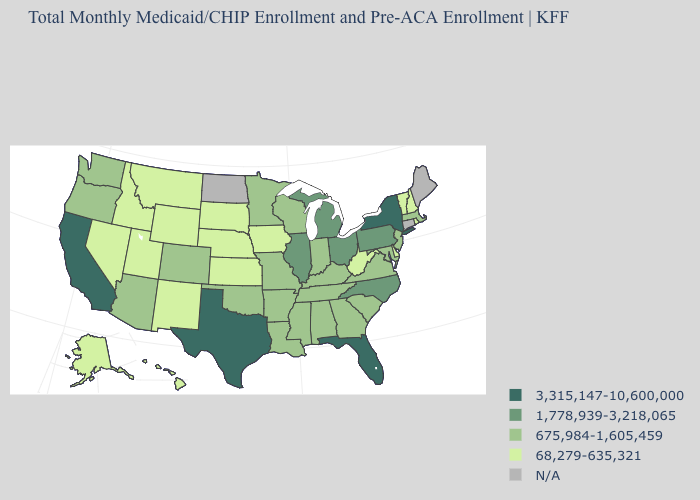What is the highest value in states that border New Jersey?
Give a very brief answer. 3,315,147-10,600,000. Does Idaho have the lowest value in the West?
Short answer required. Yes. What is the lowest value in the Northeast?
Give a very brief answer. 68,279-635,321. Name the states that have a value in the range 68,279-635,321?
Short answer required. Alaska, Delaware, Hawaii, Idaho, Iowa, Kansas, Montana, Nebraska, Nevada, New Hampshire, New Mexico, Rhode Island, South Dakota, Utah, Vermont, West Virginia, Wyoming. Does the first symbol in the legend represent the smallest category?
Short answer required. No. Which states have the lowest value in the West?
Short answer required. Alaska, Hawaii, Idaho, Montana, Nevada, New Mexico, Utah, Wyoming. Name the states that have a value in the range 675,984-1,605,459?
Answer briefly. Alabama, Arizona, Arkansas, Colorado, Georgia, Indiana, Kentucky, Louisiana, Maryland, Massachusetts, Minnesota, Mississippi, Missouri, New Jersey, Oklahoma, Oregon, South Carolina, Tennessee, Virginia, Washington, Wisconsin. What is the lowest value in states that border New York?
Write a very short answer. 68,279-635,321. Name the states that have a value in the range N/A?
Be succinct. Connecticut, Maine, North Dakota. What is the highest value in the West ?
Answer briefly. 3,315,147-10,600,000. What is the value of Oregon?
Answer briefly. 675,984-1,605,459. Does New York have the highest value in the USA?
Short answer required. Yes. Does New Mexico have the lowest value in the West?
Quick response, please. Yes. What is the value of Pennsylvania?
Concise answer only. 1,778,939-3,218,065. 